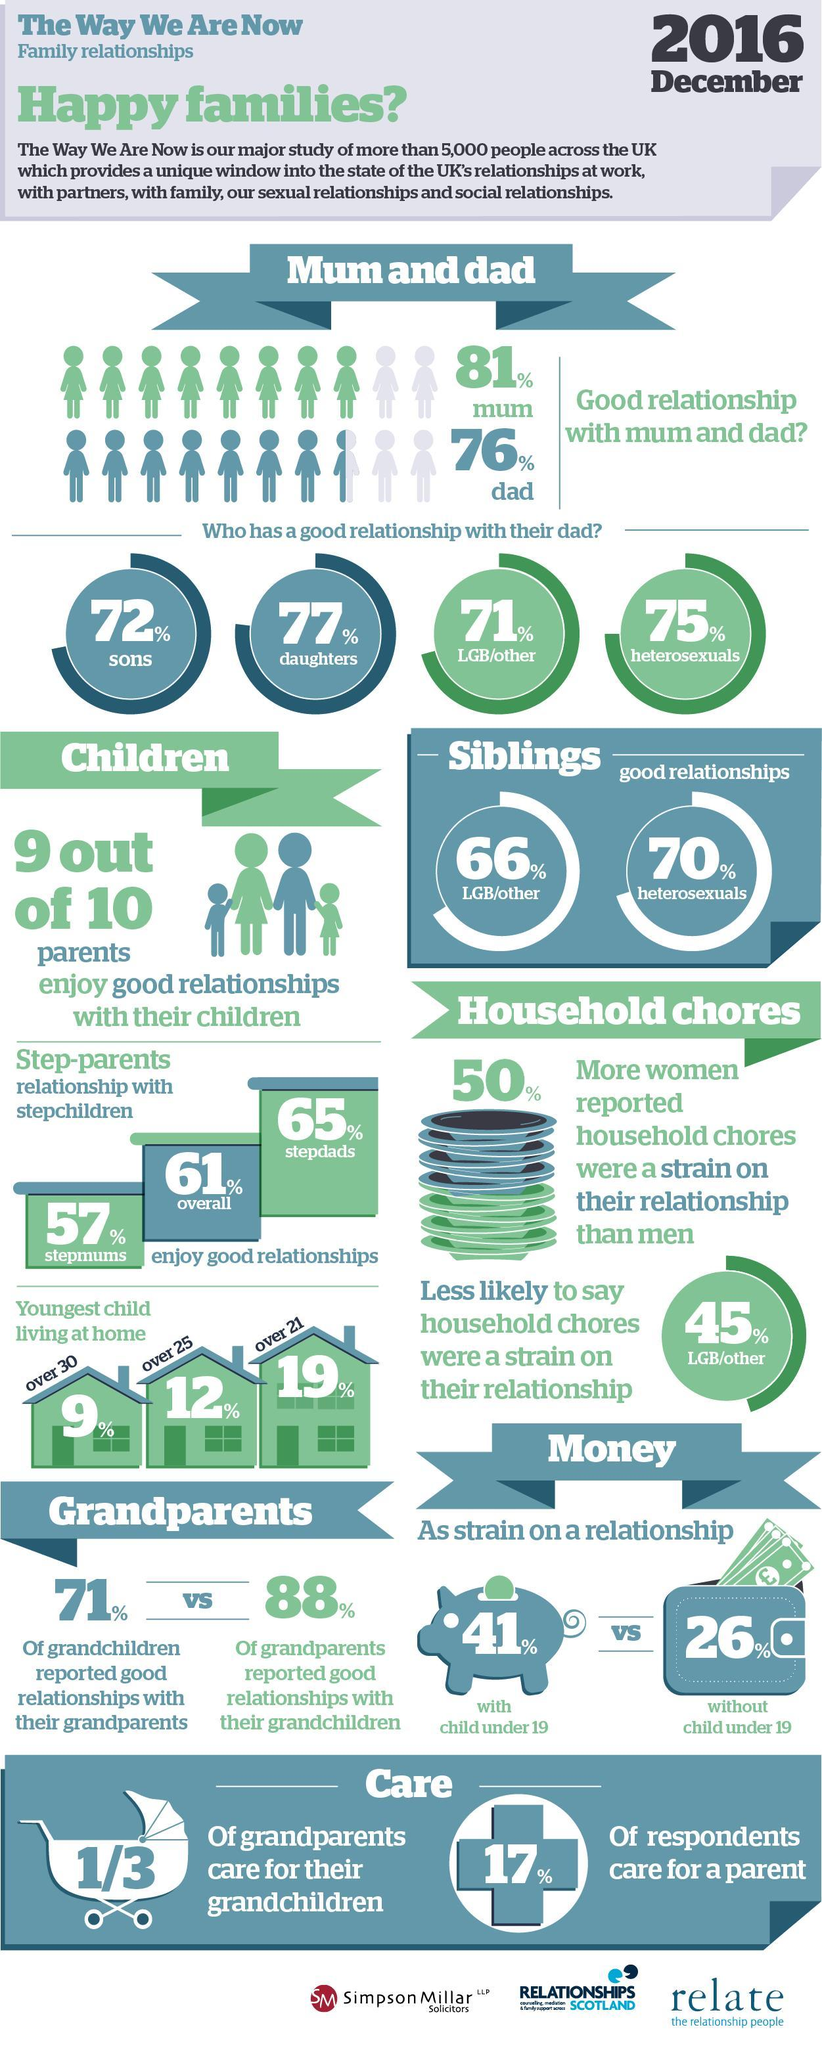Who enjoys good relationship with stepchildren the most?
Answer the question with a short phrase. stepdads What percentage of parents enjoy good relationships with their children? 90% What percentage of grandparents care for their grandchildren? 33.33% Who enjoys good relationship with their dad most? daughters Who enjoys good relationship with siblings more? heterosexuals How many of the respondents care care for a parent? 17% 